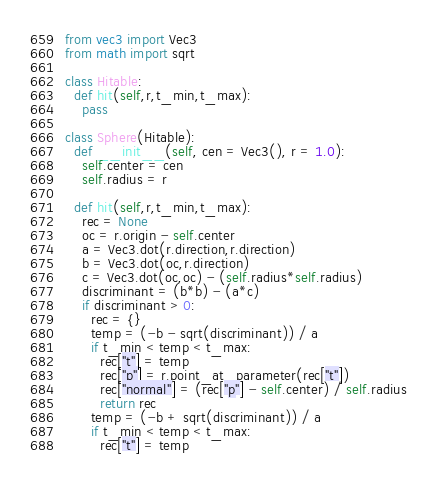<code> <loc_0><loc_0><loc_500><loc_500><_Python_>from vec3 import Vec3
from math import sqrt

class Hitable:
  def hit(self,r,t_min,t_max):
    pass

class Sphere(Hitable):
  def __init__(self, cen = Vec3(), r = 1.0):
    self.center = cen
    self.radius = r

  def hit(self,r,t_min,t_max):
    rec = None
    oc = r.origin - self.center
    a = Vec3.dot(r.direction,r.direction)
    b = Vec3.dot(oc,r.direction)
    c = Vec3.dot(oc,oc) - (self.radius*self.radius)
    discriminant = (b*b) - (a*c)
    if discriminant > 0:
      rec = {}
      temp = (-b - sqrt(discriminant)) / a
      if t_min < temp < t_max:
        rec["t"] = temp
        rec["p"] = r.point_at_parameter(rec["t"])
        rec["normal"] = (rec["p"] - self.center) / self.radius
        return rec
      temp = (-b + sqrt(discriminant)) / a
      if t_min < temp < t_max:
        rec["t"] = temp</code> 